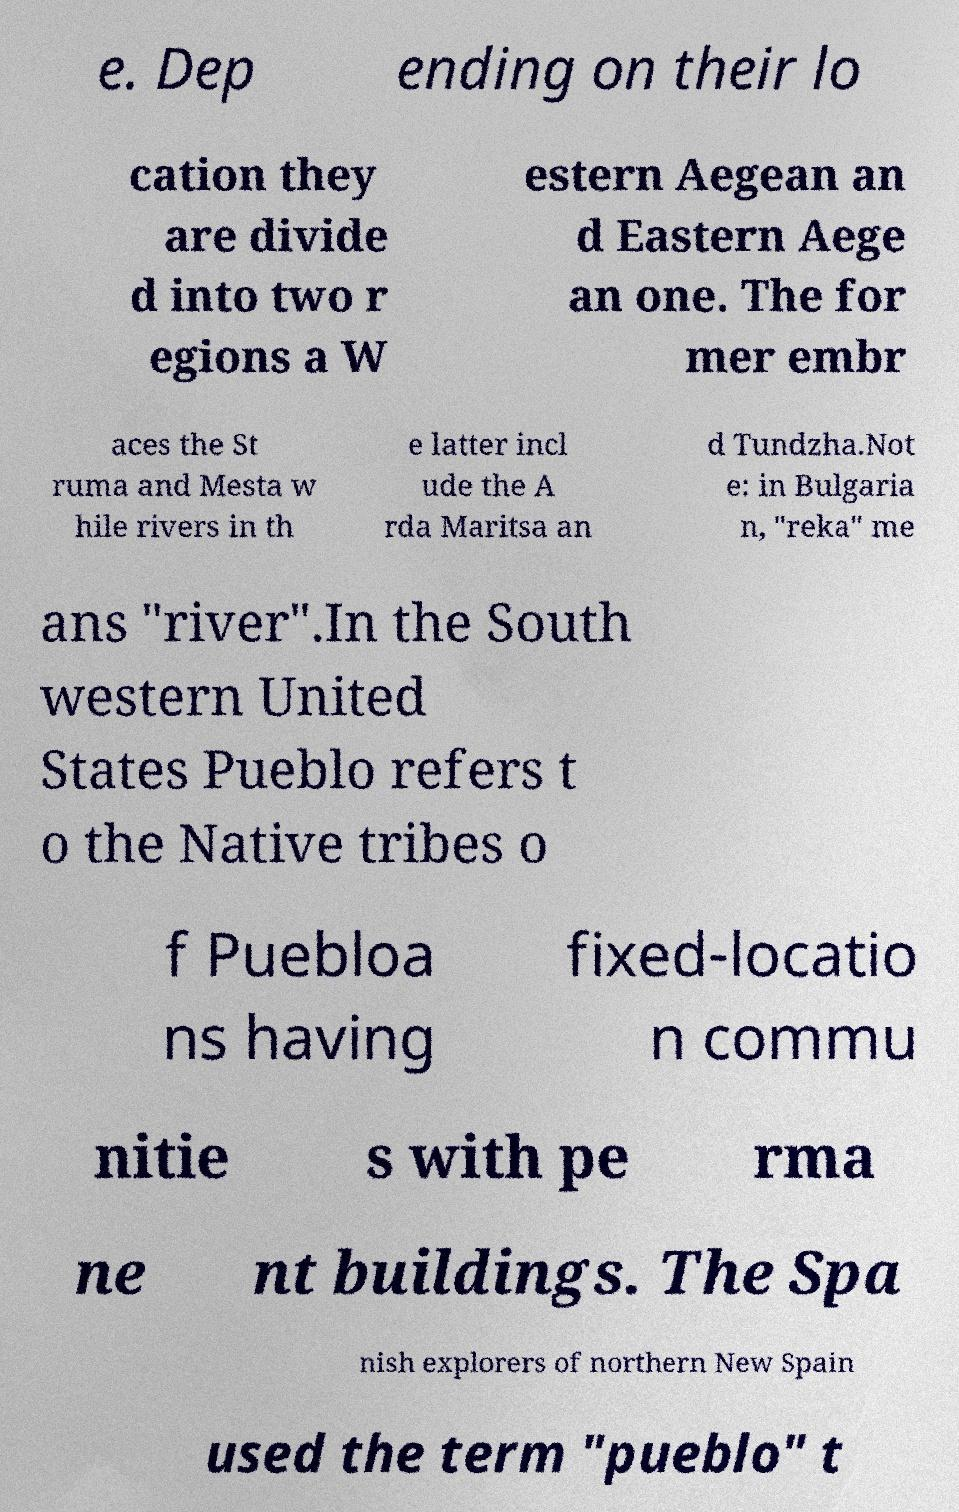Please read and relay the text visible in this image. What does it say? e. Dep ending on their lo cation they are divide d into two r egions a W estern Aegean an d Eastern Aege an one. The for mer embr aces the St ruma and Mesta w hile rivers in th e latter incl ude the A rda Maritsa an d Tundzha.Not e: in Bulgaria n, "reka" me ans "river".In the South western United States Pueblo refers t o the Native tribes o f Puebloa ns having fixed-locatio n commu nitie s with pe rma ne nt buildings. The Spa nish explorers of northern New Spain used the term "pueblo" t 